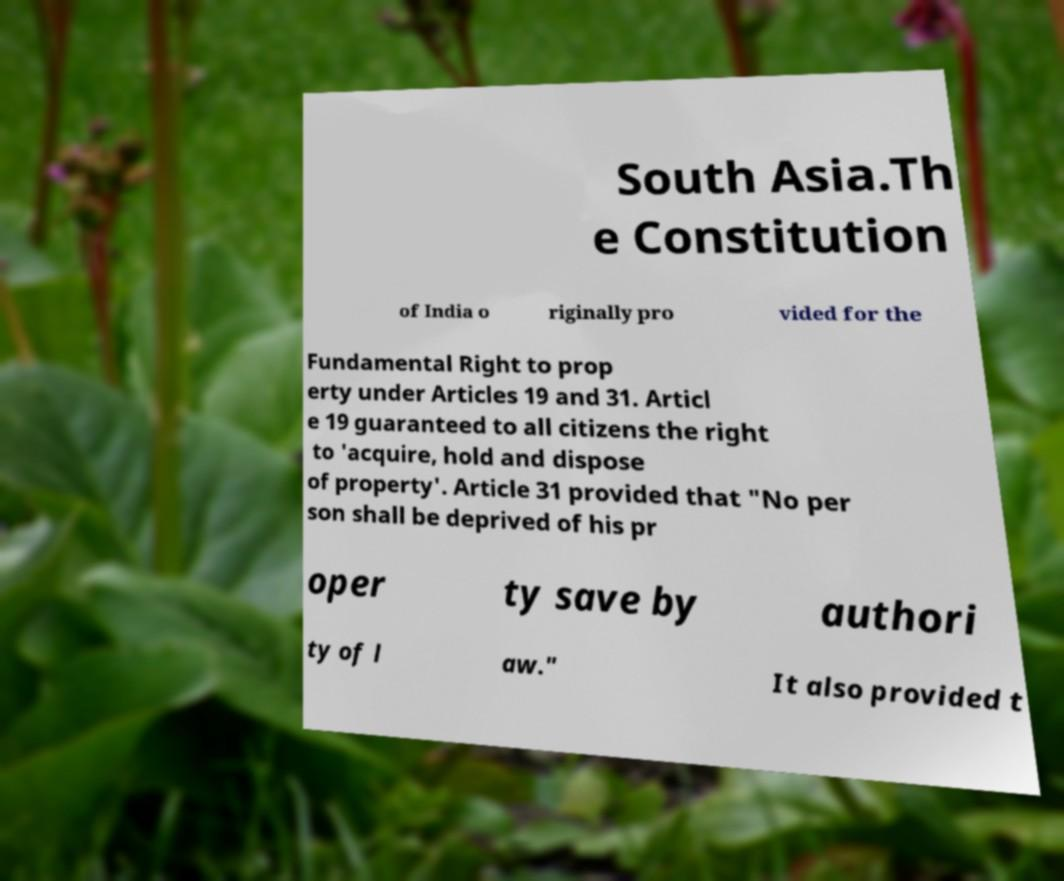Could you assist in decoding the text presented in this image and type it out clearly? South Asia.Th e Constitution of India o riginally pro vided for the Fundamental Right to prop erty under Articles 19 and 31. Articl e 19 guaranteed to all citizens the right to 'acquire, hold and dispose of property'. Article 31 provided that "No per son shall be deprived of his pr oper ty save by authori ty of l aw." It also provided t 